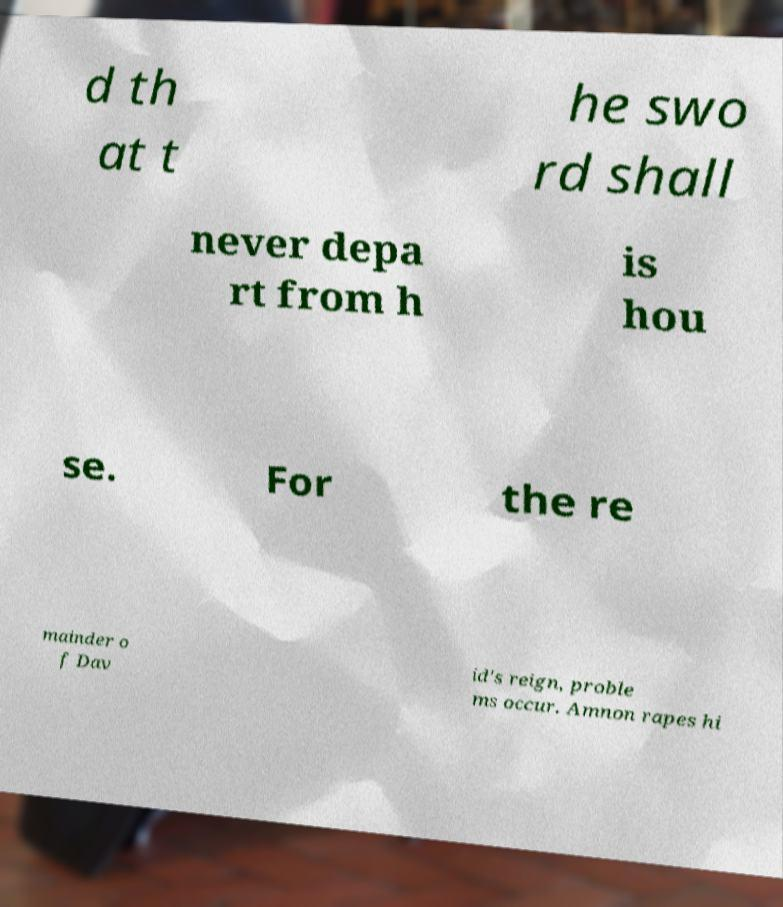For documentation purposes, I need the text within this image transcribed. Could you provide that? d th at t he swo rd shall never depa rt from h is hou se. For the re mainder o f Dav id's reign, proble ms occur. Amnon rapes hi 